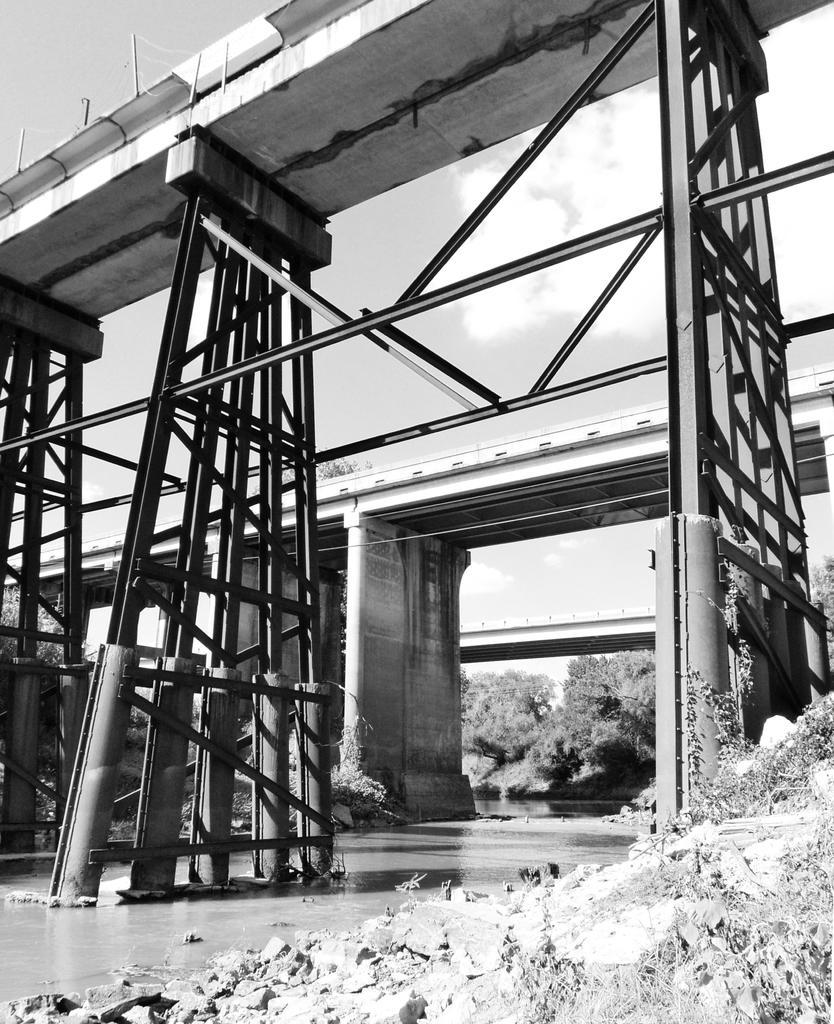Please provide a concise description of this image. It is a black and white image and in this image we can see three bridges. We can also the trees. At the top there is a cloudy sky and at the bottom we can see the water. 